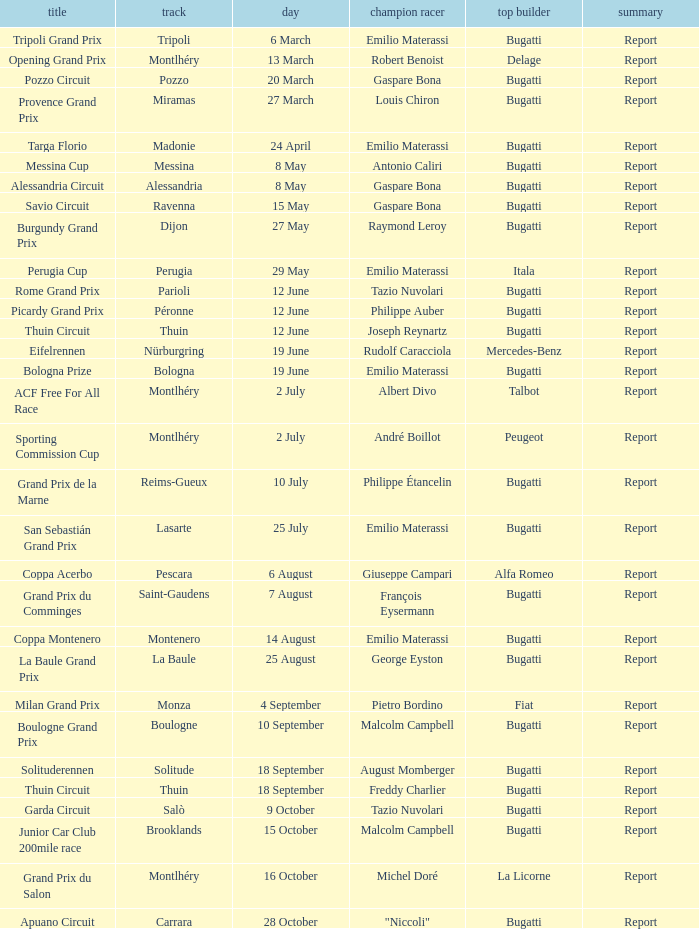Who was the winning constructor at the circuit of parioli? Bugatti. 